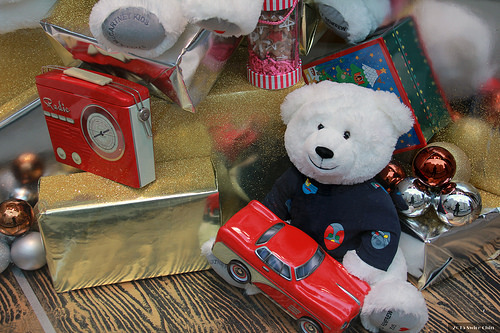<image>
Is there a ornament behind the toy car? No. The ornament is not behind the toy car. From this viewpoint, the ornament appears to be positioned elsewhere in the scene. Is there a bear next to the radio? Yes. The bear is positioned adjacent to the radio, located nearby in the same general area. 